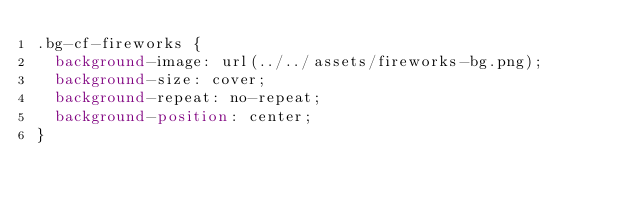<code> <loc_0><loc_0><loc_500><loc_500><_CSS_>.bg-cf-fireworks {
  background-image: url(../../assets/fireworks-bg.png);
  background-size: cover;
  background-repeat: no-repeat;
  background-position: center;
}
</code> 